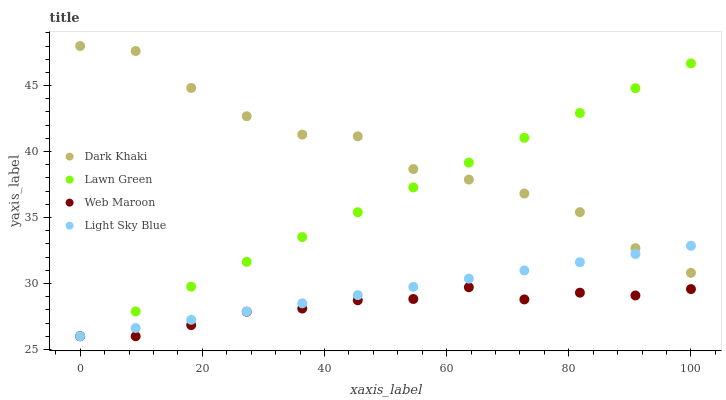Does Web Maroon have the minimum area under the curve?
Answer yes or no. Yes. Does Dark Khaki have the maximum area under the curve?
Answer yes or no. Yes. Does Lawn Green have the minimum area under the curve?
Answer yes or no. No. Does Lawn Green have the maximum area under the curve?
Answer yes or no. No. Is Light Sky Blue the smoothest?
Answer yes or no. Yes. Is Dark Khaki the roughest?
Answer yes or no. Yes. Is Lawn Green the smoothest?
Answer yes or no. No. Is Lawn Green the roughest?
Answer yes or no. No. Does Lawn Green have the lowest value?
Answer yes or no. Yes. Does Dark Khaki have the highest value?
Answer yes or no. Yes. Does Lawn Green have the highest value?
Answer yes or no. No. Is Web Maroon less than Dark Khaki?
Answer yes or no. Yes. Is Dark Khaki greater than Web Maroon?
Answer yes or no. Yes. Does Lawn Green intersect Dark Khaki?
Answer yes or no. Yes. Is Lawn Green less than Dark Khaki?
Answer yes or no. No. Is Lawn Green greater than Dark Khaki?
Answer yes or no. No. Does Web Maroon intersect Dark Khaki?
Answer yes or no. No. 